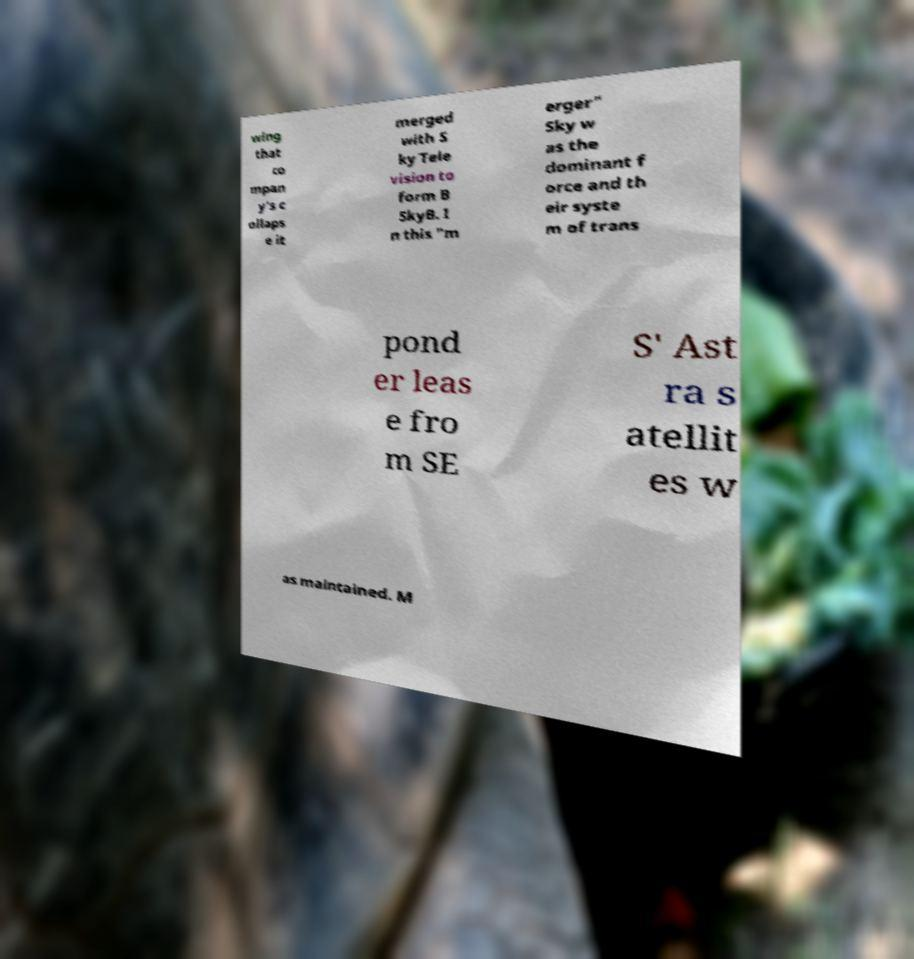Please identify and transcribe the text found in this image. wing that co mpan y's c ollaps e it merged with S ky Tele vision to form B SkyB. I n this "m erger" Sky w as the dominant f orce and th eir syste m of trans pond er leas e fro m SE S' Ast ra s atellit es w as maintained. M 